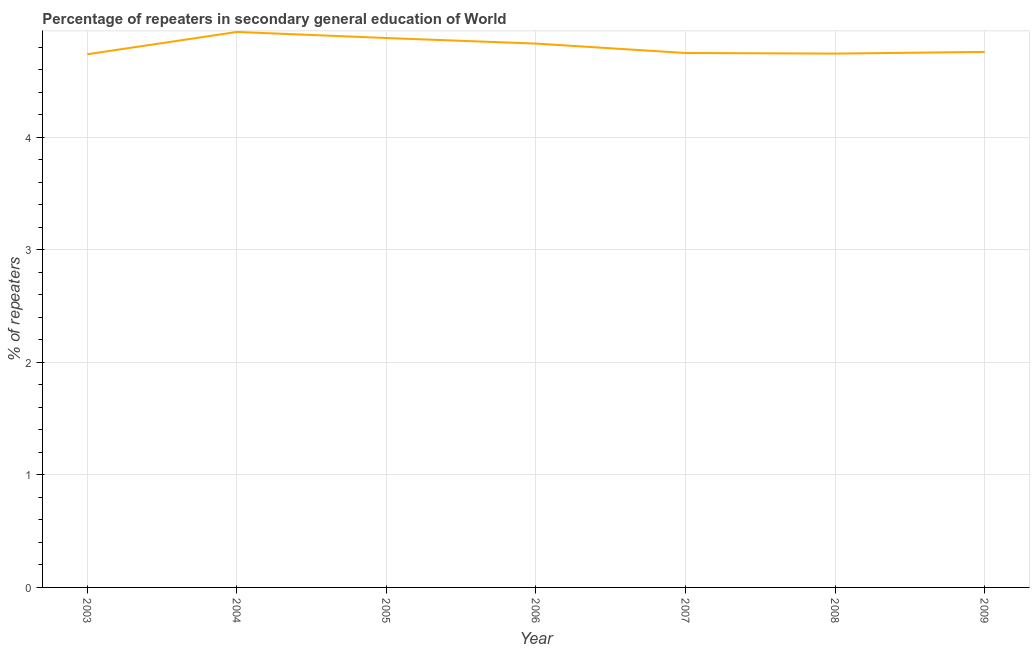What is the percentage of repeaters in 2005?
Give a very brief answer. 4.88. Across all years, what is the maximum percentage of repeaters?
Ensure brevity in your answer.  4.94. Across all years, what is the minimum percentage of repeaters?
Make the answer very short. 4.74. In which year was the percentage of repeaters maximum?
Your answer should be very brief. 2004. In which year was the percentage of repeaters minimum?
Keep it short and to the point. 2003. What is the sum of the percentage of repeaters?
Give a very brief answer. 33.64. What is the difference between the percentage of repeaters in 2007 and 2008?
Give a very brief answer. 0.01. What is the average percentage of repeaters per year?
Provide a short and direct response. 4.81. What is the median percentage of repeaters?
Ensure brevity in your answer.  4.76. In how many years, is the percentage of repeaters greater than 0.6000000000000001 %?
Provide a succinct answer. 7. Do a majority of the years between 2004 and 2008 (inclusive) have percentage of repeaters greater than 1.2 %?
Ensure brevity in your answer.  Yes. What is the ratio of the percentage of repeaters in 2004 to that in 2005?
Offer a terse response. 1.01. Is the difference between the percentage of repeaters in 2003 and 2004 greater than the difference between any two years?
Make the answer very short. Yes. What is the difference between the highest and the second highest percentage of repeaters?
Your response must be concise. 0.05. Is the sum of the percentage of repeaters in 2004 and 2007 greater than the maximum percentage of repeaters across all years?
Give a very brief answer. Yes. What is the difference between the highest and the lowest percentage of repeaters?
Provide a short and direct response. 0.2. Does the percentage of repeaters monotonically increase over the years?
Offer a terse response. No. How many years are there in the graph?
Your answer should be very brief. 7. What is the difference between two consecutive major ticks on the Y-axis?
Your answer should be very brief. 1. Does the graph contain any zero values?
Make the answer very short. No. Does the graph contain grids?
Offer a very short reply. Yes. What is the title of the graph?
Your response must be concise. Percentage of repeaters in secondary general education of World. What is the label or title of the X-axis?
Keep it short and to the point. Year. What is the label or title of the Y-axis?
Offer a very short reply. % of repeaters. What is the % of repeaters in 2003?
Ensure brevity in your answer.  4.74. What is the % of repeaters in 2004?
Offer a terse response. 4.94. What is the % of repeaters in 2005?
Your answer should be very brief. 4.88. What is the % of repeaters of 2006?
Give a very brief answer. 4.83. What is the % of repeaters in 2007?
Your answer should be compact. 4.75. What is the % of repeaters in 2008?
Keep it short and to the point. 4.74. What is the % of repeaters of 2009?
Your answer should be very brief. 4.76. What is the difference between the % of repeaters in 2003 and 2004?
Your answer should be very brief. -0.2. What is the difference between the % of repeaters in 2003 and 2005?
Offer a terse response. -0.14. What is the difference between the % of repeaters in 2003 and 2006?
Offer a very short reply. -0.09. What is the difference between the % of repeaters in 2003 and 2007?
Give a very brief answer. -0.01. What is the difference between the % of repeaters in 2003 and 2008?
Provide a succinct answer. -0.01. What is the difference between the % of repeaters in 2003 and 2009?
Provide a short and direct response. -0.02. What is the difference between the % of repeaters in 2004 and 2005?
Offer a terse response. 0.05. What is the difference between the % of repeaters in 2004 and 2006?
Ensure brevity in your answer.  0.1. What is the difference between the % of repeaters in 2004 and 2007?
Your answer should be compact. 0.19. What is the difference between the % of repeaters in 2004 and 2008?
Provide a short and direct response. 0.19. What is the difference between the % of repeaters in 2004 and 2009?
Offer a terse response. 0.18. What is the difference between the % of repeaters in 2005 and 2006?
Your answer should be compact. 0.05. What is the difference between the % of repeaters in 2005 and 2007?
Keep it short and to the point. 0.13. What is the difference between the % of repeaters in 2005 and 2008?
Offer a terse response. 0.14. What is the difference between the % of repeaters in 2005 and 2009?
Provide a succinct answer. 0.12. What is the difference between the % of repeaters in 2006 and 2007?
Provide a succinct answer. 0.08. What is the difference between the % of repeaters in 2006 and 2008?
Your response must be concise. 0.09. What is the difference between the % of repeaters in 2006 and 2009?
Offer a very short reply. 0.07. What is the difference between the % of repeaters in 2007 and 2008?
Offer a very short reply. 0.01. What is the difference between the % of repeaters in 2007 and 2009?
Provide a short and direct response. -0.01. What is the difference between the % of repeaters in 2008 and 2009?
Ensure brevity in your answer.  -0.02. What is the ratio of the % of repeaters in 2003 to that in 2006?
Make the answer very short. 0.98. What is the ratio of the % of repeaters in 2003 to that in 2008?
Offer a very short reply. 1. What is the ratio of the % of repeaters in 2003 to that in 2009?
Give a very brief answer. 1. What is the ratio of the % of repeaters in 2004 to that in 2005?
Your answer should be compact. 1.01. What is the ratio of the % of repeaters in 2004 to that in 2006?
Ensure brevity in your answer.  1.02. What is the ratio of the % of repeaters in 2004 to that in 2007?
Offer a terse response. 1.04. What is the ratio of the % of repeaters in 2004 to that in 2008?
Offer a terse response. 1.04. What is the ratio of the % of repeaters in 2004 to that in 2009?
Offer a very short reply. 1.04. What is the ratio of the % of repeaters in 2005 to that in 2006?
Offer a terse response. 1.01. What is the ratio of the % of repeaters in 2005 to that in 2007?
Provide a short and direct response. 1.03. What is the ratio of the % of repeaters in 2005 to that in 2009?
Give a very brief answer. 1.03. What is the ratio of the % of repeaters in 2006 to that in 2007?
Provide a succinct answer. 1.02. What is the ratio of the % of repeaters in 2006 to that in 2008?
Keep it short and to the point. 1.02. What is the ratio of the % of repeaters in 2007 to that in 2008?
Provide a succinct answer. 1. 